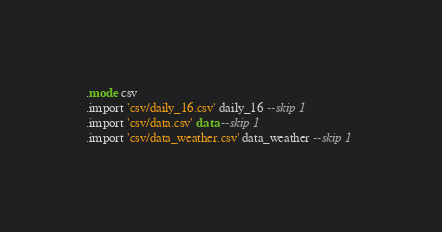<code> <loc_0><loc_0><loc_500><loc_500><_SQL_>.mode csv 
.import 'csv/daily_16.csv' daily_16 --skip 1 
.import 'csv/data.csv' data --skip 1 
.import 'csv/data_weather.csv' data_weather --skip 1 
</code> 